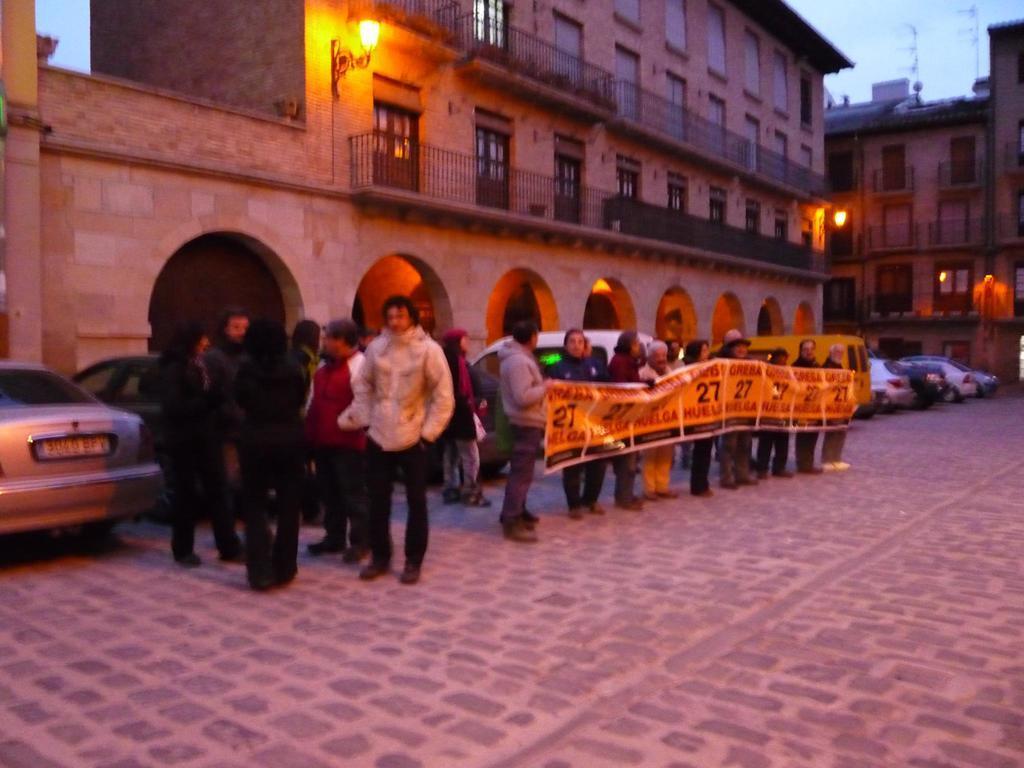Please provide a concise description of this image. In the picture we can see some group of persons standing and some are holding banner in their hands, there are some vehicles parked and in the background of the picture there are some buildings and clear sky. 